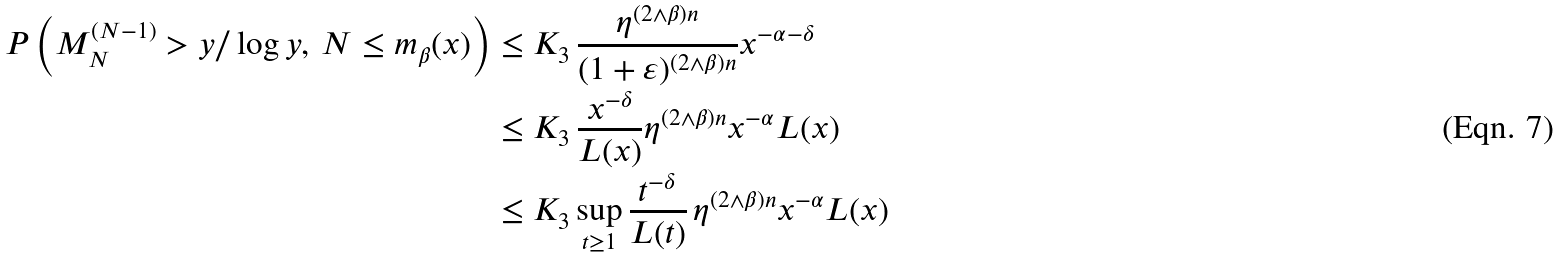Convert formula to latex. <formula><loc_0><loc_0><loc_500><loc_500>P \left ( M _ { N } ^ { ( N - 1 ) } > y / \log y , \, N \leq m _ { \beta } ( x ) \right ) & \leq K _ { 3 } \, \frac { \eta ^ { ( 2 \wedge \beta ) n } } { ( 1 + \varepsilon ) ^ { ( 2 \wedge \beta ) n } } x ^ { - \alpha - \delta } \\ & \leq K _ { 3 } \, \frac { x ^ { - \delta } } { L ( x ) } \eta ^ { ( 2 \wedge \beta ) n } x ^ { - \alpha } L ( x ) \\ & \leq K _ { 3 } \sup _ { t \geq 1 } \frac { t ^ { - \delta } } { L ( t ) } \, \eta ^ { ( 2 \wedge \beta ) n } x ^ { - \alpha } L ( x )</formula> 